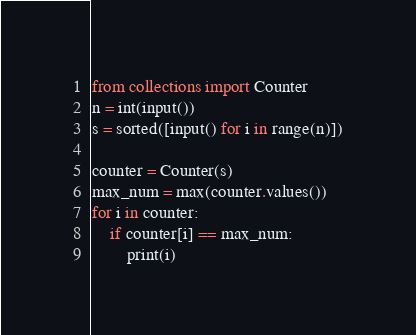Convert code to text. <code><loc_0><loc_0><loc_500><loc_500><_Python_>from collections import Counter
n = int(input())
s = sorted([input() for i in range(n)])

counter = Counter(s)
max_num = max(counter.values())
for i in counter:
    if counter[i] == max_num:
        print(i)</code> 